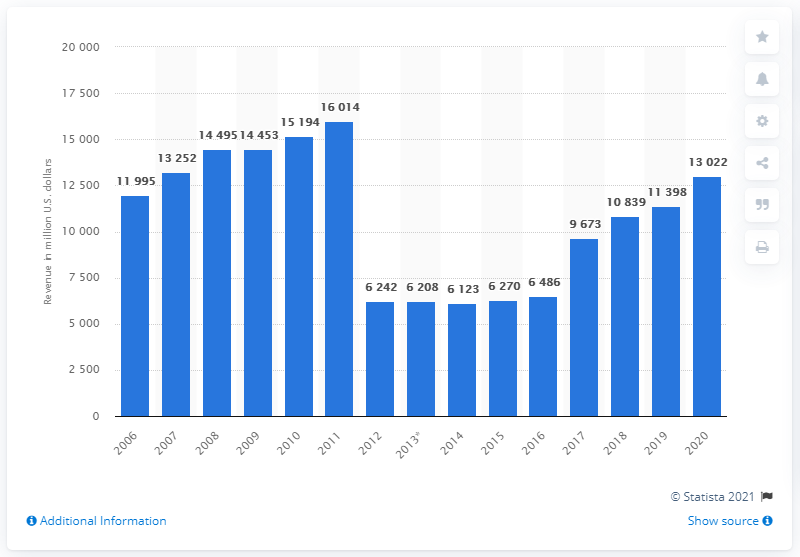Identify some key points in this picture. In the year 2020, Abbott Laboratories generated approximately $130,220,000 in revenue in the United States market. 